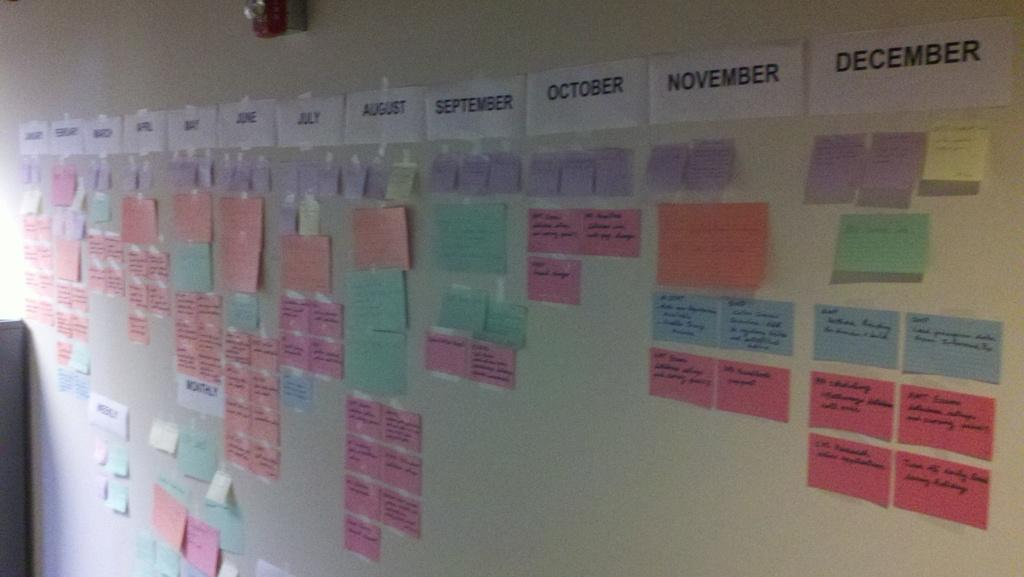Provide a one-sentence caption for the provided image. Taped to a wall is a row containing the months of the year. 